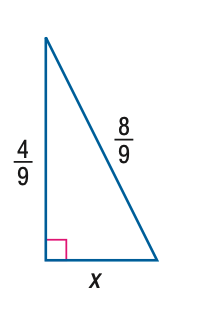Answer the mathemtical geometry problem and directly provide the correct option letter.
Question: Find x.
Choices: A: \frac { 4 } { 9 } B: \frac { 4 } { 9 } \sqrt { 2 } C: \frac { 4 } { 9 } \sqrt { 3 } D: \frac { 4 } { 9 } \sqrt { 5 } C 